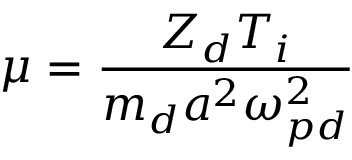Convert formula to latex. <formula><loc_0><loc_0><loc_500><loc_500>\mu = \frac { Z _ { d } T _ { i } } { m _ { d } a ^ { 2 } \omega _ { p d } ^ { 2 } }</formula> 